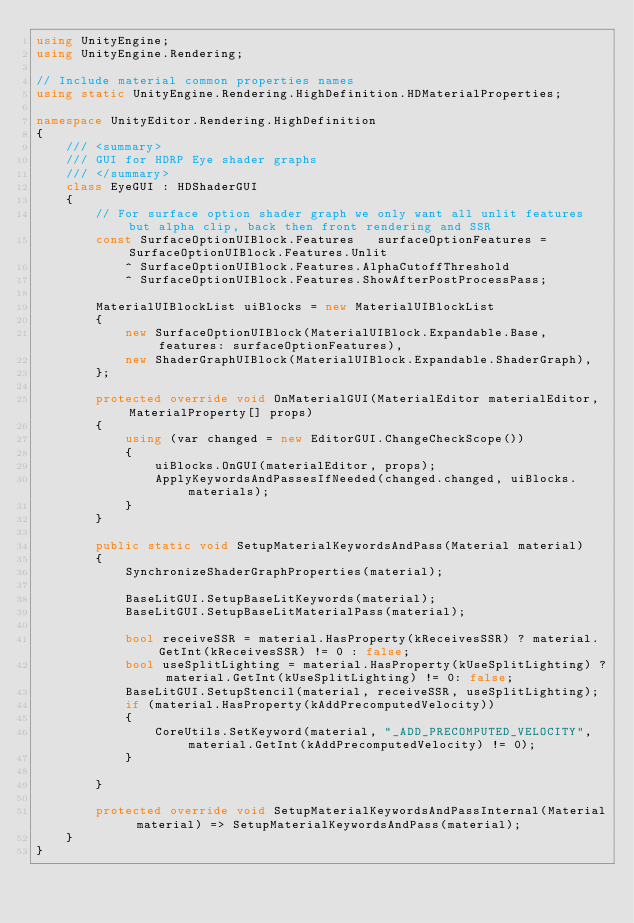<code> <loc_0><loc_0><loc_500><loc_500><_C#_>using UnityEngine;
using UnityEngine.Rendering;

// Include material common properties names
using static UnityEngine.Rendering.HighDefinition.HDMaterialProperties;

namespace UnityEditor.Rendering.HighDefinition
{
    /// <summary>
    /// GUI for HDRP Eye shader graphs
    /// </summary>
    class EyeGUI : HDShaderGUI
    {
        // For surface option shader graph we only want all unlit features but alpha clip, back then front rendering and SSR
        const SurfaceOptionUIBlock.Features   surfaceOptionFeatures = SurfaceOptionUIBlock.Features.Unlit
            ^ SurfaceOptionUIBlock.Features.AlphaCutoffThreshold
            ^ SurfaceOptionUIBlock.Features.ShowAfterPostProcessPass;

        MaterialUIBlockList uiBlocks = new MaterialUIBlockList
        {
            new SurfaceOptionUIBlock(MaterialUIBlock.Expandable.Base, features: surfaceOptionFeatures),
            new ShaderGraphUIBlock(MaterialUIBlock.Expandable.ShaderGraph),
        };

        protected override void OnMaterialGUI(MaterialEditor materialEditor, MaterialProperty[] props)
        {
            using (var changed = new EditorGUI.ChangeCheckScope())
            {
                uiBlocks.OnGUI(materialEditor, props);
                ApplyKeywordsAndPassesIfNeeded(changed.changed, uiBlocks.materials);
            }
        }

        public static void SetupMaterialKeywordsAndPass(Material material)
        {
            SynchronizeShaderGraphProperties(material);

            BaseLitGUI.SetupBaseLitKeywords(material);
            BaseLitGUI.SetupBaseLitMaterialPass(material);

            bool receiveSSR = material.HasProperty(kReceivesSSR) ? material.GetInt(kReceivesSSR) != 0 : false;
            bool useSplitLighting = material.HasProperty(kUseSplitLighting) ? material.GetInt(kUseSplitLighting) != 0: false;
            BaseLitGUI.SetupStencil(material, receiveSSR, useSplitLighting);
            if (material.HasProperty(kAddPrecomputedVelocity))
            {
                CoreUtils.SetKeyword(material, "_ADD_PRECOMPUTED_VELOCITY", material.GetInt(kAddPrecomputedVelocity) != 0);
            }

        }

        protected override void SetupMaterialKeywordsAndPassInternal(Material material) => SetupMaterialKeywordsAndPass(material);
    }
}
</code> 